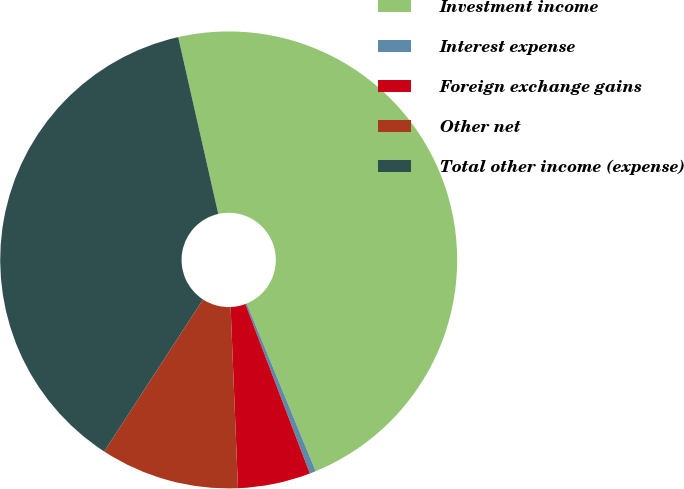Convert chart to OTSL. <chart><loc_0><loc_0><loc_500><loc_500><pie_chart><fcel>Investment income<fcel>Interest expense<fcel>Foreign exchange gains<fcel>Other net<fcel>Total other income (expense)<nl><fcel>47.33%<fcel>0.44%<fcel>5.13%<fcel>9.82%<fcel>37.28%<nl></chart> 